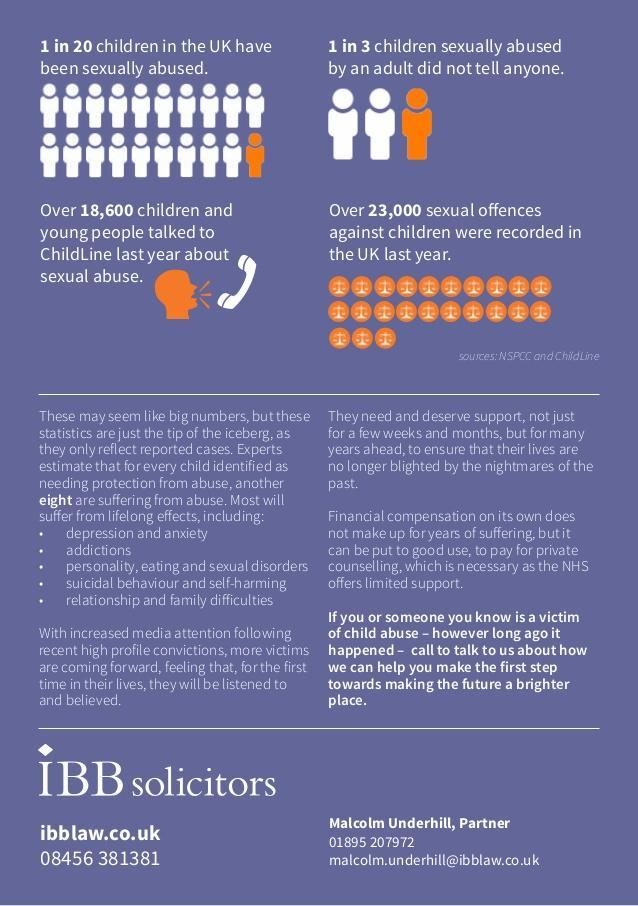What percent of children in the UK have been sexually abused?
Answer the question with a short phrase. 5 What proportion of children sexually abused by an adult told someone? 2 in 3 